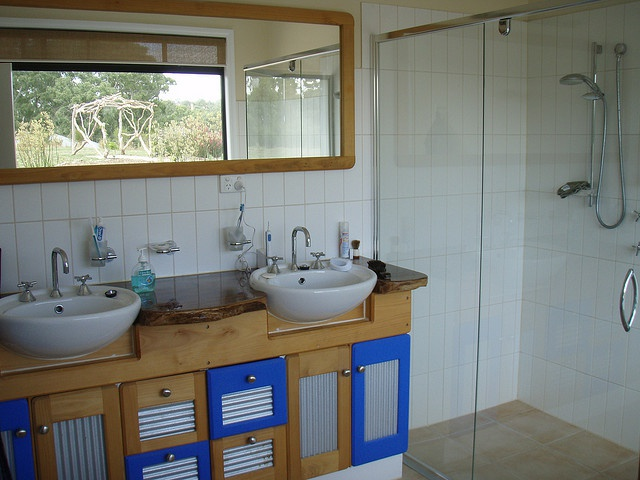Describe the objects in this image and their specific colors. I can see sink in black and gray tones, sink in black, darkgray, and gray tones, cup in black, gray, and blue tones, cup in black and gray tones, and toothbrush in black, darkgray, blue, and gray tones in this image. 